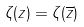<formula> <loc_0><loc_0><loc_500><loc_500>\zeta ( z ) = \zeta ( \overline { z } )</formula> 